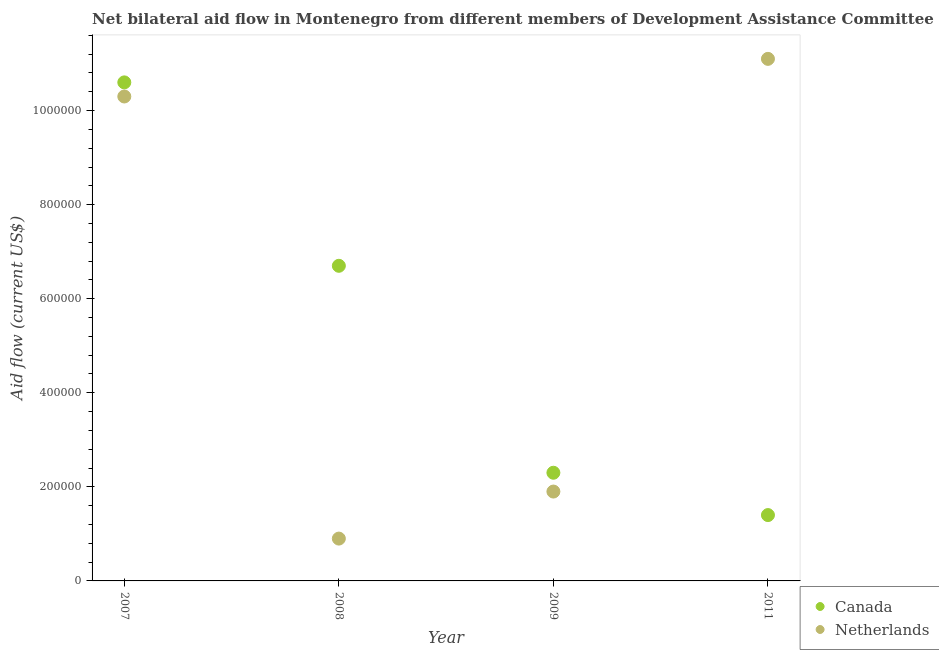How many different coloured dotlines are there?
Offer a terse response. 2. What is the amount of aid given by canada in 2009?
Your answer should be compact. 2.30e+05. Across all years, what is the maximum amount of aid given by canada?
Your response must be concise. 1.06e+06. Across all years, what is the minimum amount of aid given by canada?
Provide a short and direct response. 1.40e+05. What is the total amount of aid given by canada in the graph?
Keep it short and to the point. 2.10e+06. What is the difference between the amount of aid given by canada in 2007 and that in 2011?
Provide a succinct answer. 9.20e+05. What is the difference between the amount of aid given by canada in 2008 and the amount of aid given by netherlands in 2009?
Offer a very short reply. 4.80e+05. What is the average amount of aid given by canada per year?
Offer a terse response. 5.25e+05. In the year 2011, what is the difference between the amount of aid given by netherlands and amount of aid given by canada?
Offer a very short reply. 9.70e+05. What is the ratio of the amount of aid given by netherlands in 2007 to that in 2009?
Your answer should be very brief. 5.42. Is the amount of aid given by netherlands in 2008 less than that in 2009?
Make the answer very short. Yes. What is the difference between the highest and the second highest amount of aid given by netherlands?
Offer a very short reply. 8.00e+04. What is the difference between the highest and the lowest amount of aid given by netherlands?
Make the answer very short. 1.02e+06. In how many years, is the amount of aid given by canada greater than the average amount of aid given by canada taken over all years?
Make the answer very short. 2. Is the amount of aid given by netherlands strictly greater than the amount of aid given by canada over the years?
Keep it short and to the point. No. What is the difference between two consecutive major ticks on the Y-axis?
Your answer should be very brief. 2.00e+05. Are the values on the major ticks of Y-axis written in scientific E-notation?
Make the answer very short. No. Does the graph contain any zero values?
Give a very brief answer. No. Does the graph contain grids?
Your answer should be very brief. No. How are the legend labels stacked?
Make the answer very short. Vertical. What is the title of the graph?
Make the answer very short. Net bilateral aid flow in Montenegro from different members of Development Assistance Committee. Does "Food and tobacco" appear as one of the legend labels in the graph?
Ensure brevity in your answer.  No. What is the label or title of the X-axis?
Your answer should be very brief. Year. What is the label or title of the Y-axis?
Give a very brief answer. Aid flow (current US$). What is the Aid flow (current US$) of Canada in 2007?
Your answer should be very brief. 1.06e+06. What is the Aid flow (current US$) in Netherlands in 2007?
Offer a very short reply. 1.03e+06. What is the Aid flow (current US$) of Canada in 2008?
Provide a succinct answer. 6.70e+05. What is the Aid flow (current US$) in Netherlands in 2009?
Your answer should be very brief. 1.90e+05. What is the Aid flow (current US$) in Canada in 2011?
Make the answer very short. 1.40e+05. What is the Aid flow (current US$) in Netherlands in 2011?
Keep it short and to the point. 1.11e+06. Across all years, what is the maximum Aid flow (current US$) of Canada?
Offer a very short reply. 1.06e+06. Across all years, what is the maximum Aid flow (current US$) of Netherlands?
Provide a short and direct response. 1.11e+06. What is the total Aid flow (current US$) in Canada in the graph?
Make the answer very short. 2.10e+06. What is the total Aid flow (current US$) in Netherlands in the graph?
Provide a short and direct response. 2.42e+06. What is the difference between the Aid flow (current US$) in Netherlands in 2007 and that in 2008?
Your answer should be very brief. 9.40e+05. What is the difference between the Aid flow (current US$) in Canada in 2007 and that in 2009?
Give a very brief answer. 8.30e+05. What is the difference between the Aid flow (current US$) of Netherlands in 2007 and that in 2009?
Keep it short and to the point. 8.40e+05. What is the difference between the Aid flow (current US$) of Canada in 2007 and that in 2011?
Provide a succinct answer. 9.20e+05. What is the difference between the Aid flow (current US$) of Canada in 2008 and that in 2009?
Offer a very short reply. 4.40e+05. What is the difference between the Aid flow (current US$) in Netherlands in 2008 and that in 2009?
Provide a succinct answer. -1.00e+05. What is the difference between the Aid flow (current US$) of Canada in 2008 and that in 2011?
Give a very brief answer. 5.30e+05. What is the difference between the Aid flow (current US$) in Netherlands in 2008 and that in 2011?
Offer a very short reply. -1.02e+06. What is the difference between the Aid flow (current US$) in Canada in 2009 and that in 2011?
Your response must be concise. 9.00e+04. What is the difference between the Aid flow (current US$) in Netherlands in 2009 and that in 2011?
Offer a terse response. -9.20e+05. What is the difference between the Aid flow (current US$) in Canada in 2007 and the Aid flow (current US$) in Netherlands in 2008?
Provide a succinct answer. 9.70e+05. What is the difference between the Aid flow (current US$) in Canada in 2007 and the Aid flow (current US$) in Netherlands in 2009?
Ensure brevity in your answer.  8.70e+05. What is the difference between the Aid flow (current US$) in Canada in 2007 and the Aid flow (current US$) in Netherlands in 2011?
Keep it short and to the point. -5.00e+04. What is the difference between the Aid flow (current US$) of Canada in 2008 and the Aid flow (current US$) of Netherlands in 2011?
Offer a very short reply. -4.40e+05. What is the difference between the Aid flow (current US$) in Canada in 2009 and the Aid flow (current US$) in Netherlands in 2011?
Provide a succinct answer. -8.80e+05. What is the average Aid flow (current US$) of Canada per year?
Your answer should be very brief. 5.25e+05. What is the average Aid flow (current US$) of Netherlands per year?
Provide a succinct answer. 6.05e+05. In the year 2007, what is the difference between the Aid flow (current US$) in Canada and Aid flow (current US$) in Netherlands?
Ensure brevity in your answer.  3.00e+04. In the year 2008, what is the difference between the Aid flow (current US$) in Canada and Aid flow (current US$) in Netherlands?
Provide a short and direct response. 5.80e+05. In the year 2009, what is the difference between the Aid flow (current US$) of Canada and Aid flow (current US$) of Netherlands?
Ensure brevity in your answer.  4.00e+04. In the year 2011, what is the difference between the Aid flow (current US$) in Canada and Aid flow (current US$) in Netherlands?
Provide a short and direct response. -9.70e+05. What is the ratio of the Aid flow (current US$) of Canada in 2007 to that in 2008?
Offer a very short reply. 1.58. What is the ratio of the Aid flow (current US$) of Netherlands in 2007 to that in 2008?
Provide a succinct answer. 11.44. What is the ratio of the Aid flow (current US$) of Canada in 2007 to that in 2009?
Make the answer very short. 4.61. What is the ratio of the Aid flow (current US$) in Netherlands in 2007 to that in 2009?
Provide a succinct answer. 5.42. What is the ratio of the Aid flow (current US$) of Canada in 2007 to that in 2011?
Provide a succinct answer. 7.57. What is the ratio of the Aid flow (current US$) of Netherlands in 2007 to that in 2011?
Provide a succinct answer. 0.93. What is the ratio of the Aid flow (current US$) in Canada in 2008 to that in 2009?
Offer a terse response. 2.91. What is the ratio of the Aid flow (current US$) in Netherlands in 2008 to that in 2009?
Keep it short and to the point. 0.47. What is the ratio of the Aid flow (current US$) in Canada in 2008 to that in 2011?
Your response must be concise. 4.79. What is the ratio of the Aid flow (current US$) of Netherlands in 2008 to that in 2011?
Keep it short and to the point. 0.08. What is the ratio of the Aid flow (current US$) of Canada in 2009 to that in 2011?
Give a very brief answer. 1.64. What is the ratio of the Aid flow (current US$) of Netherlands in 2009 to that in 2011?
Your answer should be compact. 0.17. What is the difference between the highest and the second highest Aid flow (current US$) of Canada?
Your answer should be very brief. 3.90e+05. What is the difference between the highest and the lowest Aid flow (current US$) of Canada?
Provide a short and direct response. 9.20e+05. What is the difference between the highest and the lowest Aid flow (current US$) in Netherlands?
Offer a terse response. 1.02e+06. 